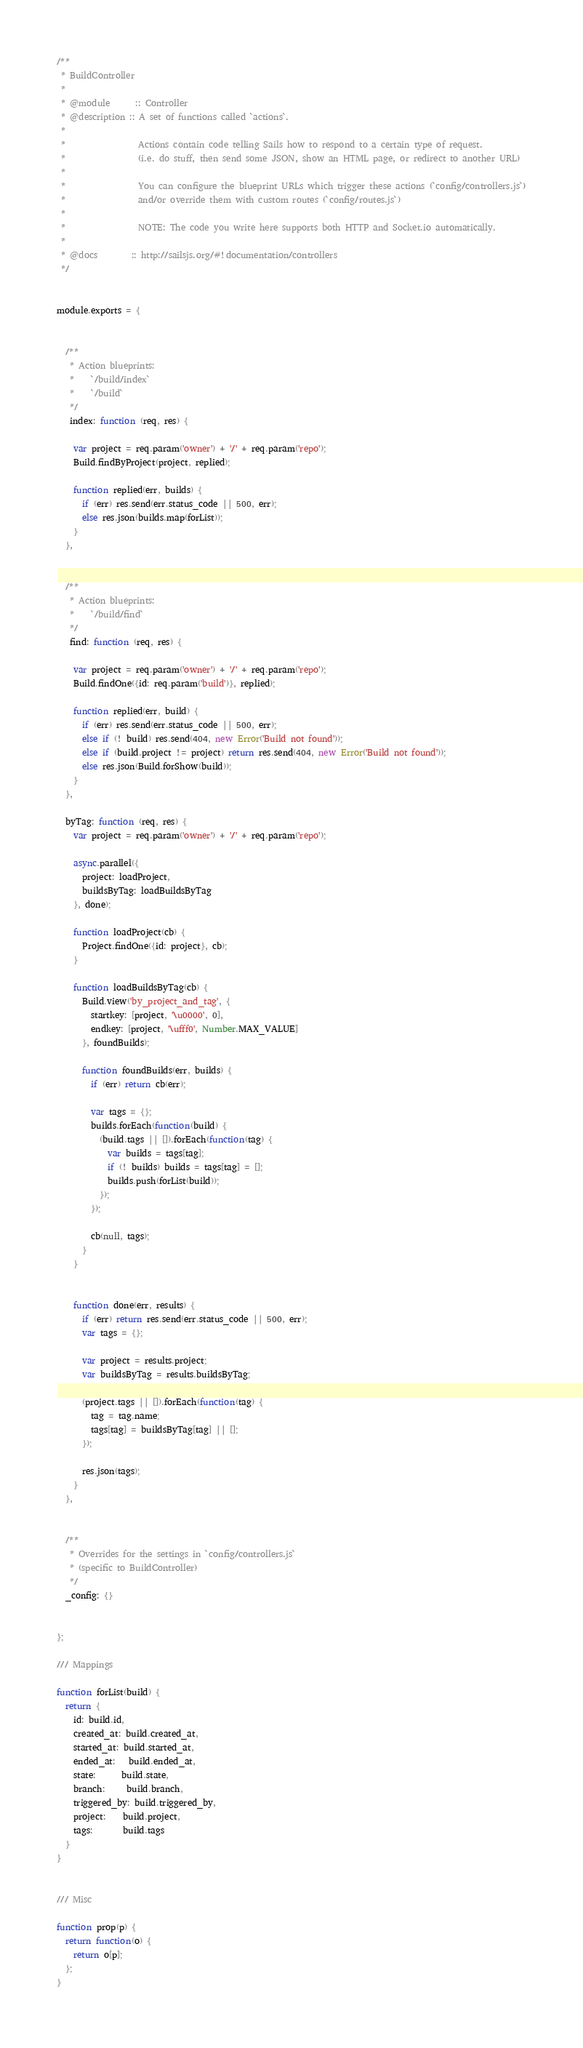<code> <loc_0><loc_0><loc_500><loc_500><_JavaScript_>/**
 * BuildController
 *
 * @module      :: Controller
 * @description	:: A set of functions called `actions`.
 *
 *                 Actions contain code telling Sails how to respond to a certain type of request.
 *                 (i.e. do stuff, then send some JSON, show an HTML page, or redirect to another URL)
 *
 *                 You can configure the blueprint URLs which trigger these actions (`config/controllers.js`)
 *                 and/or override them with custom routes (`config/routes.js`)
 *
 *                 NOTE: The code you write here supports both HTTP and Socket.io automatically.
 *
 * @docs        :: http://sailsjs.org/#!documentation/controllers
 */


module.exports = {


  /**
   * Action blueprints:
   *    `/build/index`
   *    `/build`
   */
   index: function (req, res) {

    var project = req.param('owner') + '/' + req.param('repo');
    Build.findByProject(project, replied);

    function replied(err, builds) {
      if (err) res.send(err.status_code || 500, err);
      else res.json(builds.map(forList));
    }
  },


  /**
   * Action blueprints:
   *    `/build/find`
   */
   find: function (req, res) {

    var project = req.param('owner') + '/' + req.param('repo');
    Build.findOne({id: req.param('build')}, replied);

    function replied(err, build) {
      if (err) res.send(err.status_code || 500, err);
      else if (! build) res.send(404, new Error('Build not found'));
      else if (build.project != project) return res.send(404, new Error('Build not found'));
      else res.json(Build.forShow(build));
    }
  },

  byTag: function (req, res) {
    var project = req.param('owner') + '/' + req.param('repo');

    async.parallel({
      project: loadProject,
      buildsByTag: loadBuildsByTag
    }, done);

    function loadProject(cb) {
      Project.findOne({id: project}, cb);
    }

    function loadBuildsByTag(cb) {
      Build.view('by_project_and_tag', {
        startkey: [project, '\u0000', 0],
        endkey: [project, '\ufff0', Number.MAX_VALUE]
      }, foundBuilds);

      function foundBuilds(err, builds) {
        if (err) return cb(err);

        var tags = {};
        builds.forEach(function(build) {
          (build.tags || []).forEach(function(tag) {
            var builds = tags[tag];
            if (! builds) builds = tags[tag] = [];
            builds.push(forList(build));
          });
        });

        cb(null, tags);
      }
    }


    function done(err, results) {
      if (err) return res.send(err.status_code || 500, err);
      var tags = {};

      var project = results.project;
      var buildsByTag = results.buildsByTag;

      (project.tags || []).forEach(function(tag) {
        tag = tag.name;
        tags[tag] = buildsByTag[tag] || [];
      });

      res.json(tags);
    }
  },


  /**
   * Overrides for the settings in `config/controllers.js`
   * (specific to BuildController)
   */
  _config: {}


};

/// Mappings

function forList(build) {
  return {
    id: build.id,
    created_at: build.created_at,
    started_at: build.started_at,
    ended_at:   build.ended_at,
    state:      build.state,
    branch:     build.branch,
    triggered_by: build.triggered_by,
    project:    build.project,
    tags:       build.tags
  }
}


/// Misc

function prop(p) {
  return function(o) {
    return o[p];
  };
}</code> 